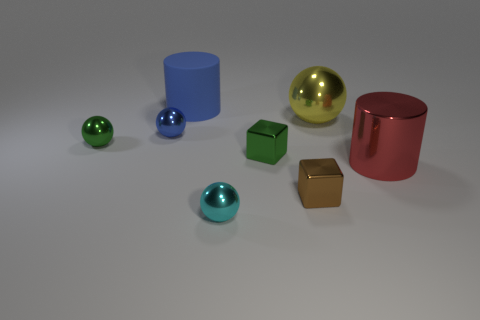Subtract all cyan shiny spheres. How many spheres are left? 3 Subtract all yellow balls. How many balls are left? 3 Add 2 purple metal balls. How many objects exist? 10 Subtract all cylinders. How many objects are left? 6 Subtract all purple spheres. Subtract all green cubes. How many spheres are left? 4 Subtract all tiny green spheres. Subtract all large yellow metallic spheres. How many objects are left? 6 Add 4 brown metallic things. How many brown metallic things are left? 5 Add 8 large cylinders. How many large cylinders exist? 10 Subtract 0 yellow cylinders. How many objects are left? 8 